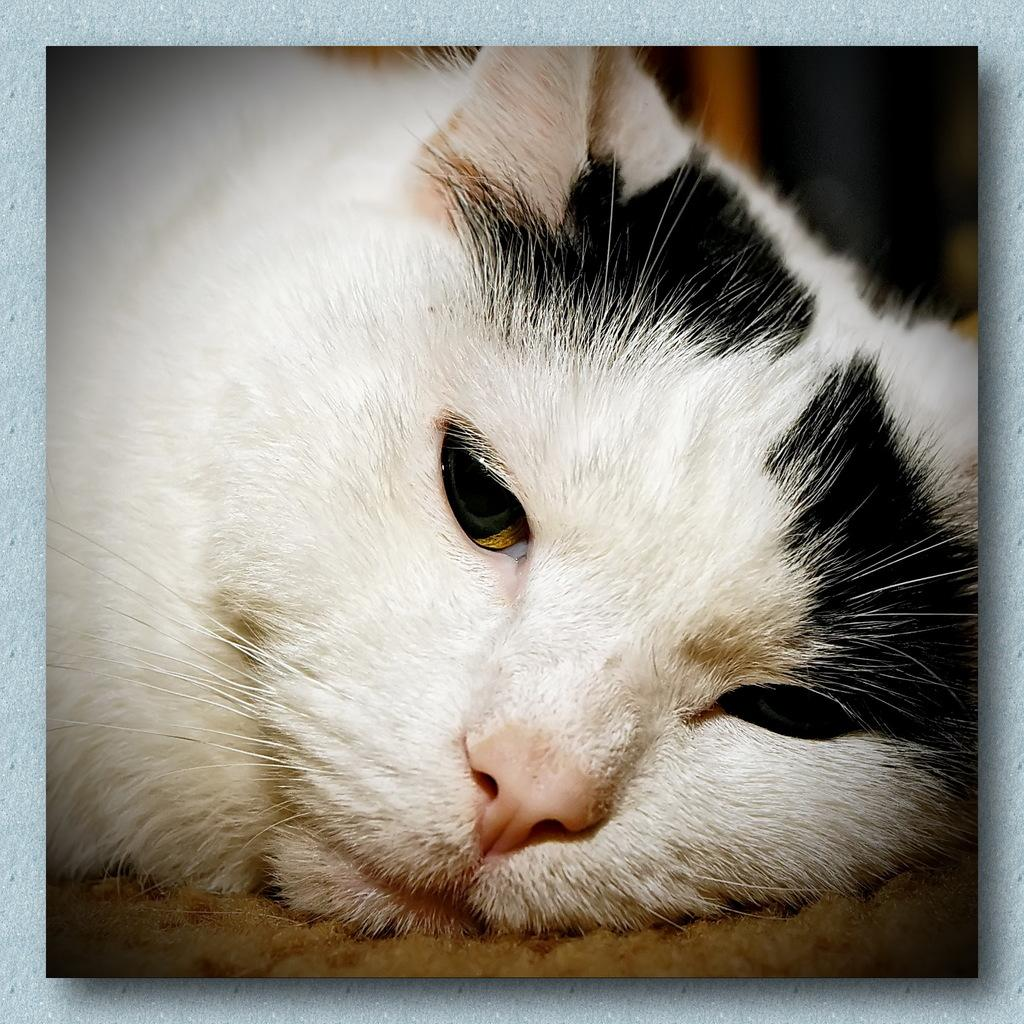What type of animal is present in the image? There is a cat in the image. What type of soup is being served in the image? There is no soup present in the image; it only features a cat. How many cubs are visible in the image? There are no cubs present in the image; it only features a cat. 